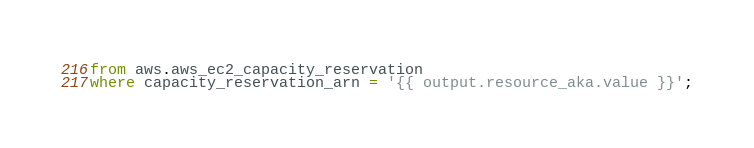Convert code to text. <code><loc_0><loc_0><loc_500><loc_500><_SQL_>from aws.aws_ec2_capacity_reservation
where capacity_reservation_arn = '{{ output.resource_aka.value }}';
</code> 